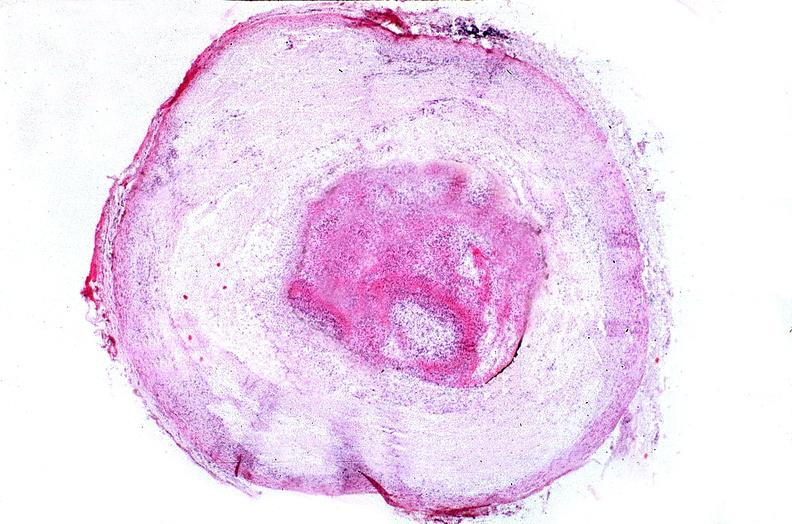what does this image show?
Answer the question using a single word or phrase. Coronary artery with atherosclerosis and thrombotic occlusion 